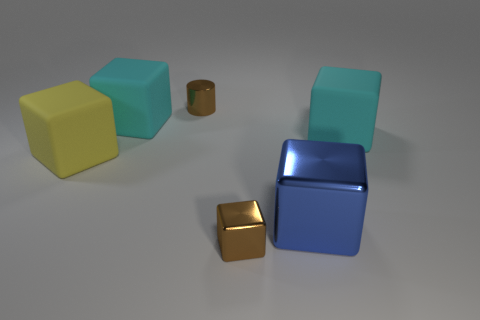What material is the small brown cylinder?
Ensure brevity in your answer.  Metal. There is a metal thing that is behind the blue metal thing; is its shape the same as the blue metal object?
Ensure brevity in your answer.  No. There is a thing that is the same color as the small cube; what is its size?
Your answer should be compact. Small. Are there any blue things that have the same size as the yellow rubber thing?
Keep it short and to the point. Yes. There is a big matte object that is to the right of the tiny thing behind the blue cube; are there any big blue metal blocks behind it?
Give a very brief answer. No. There is a tiny metallic cylinder; does it have the same color as the small shiny thing that is in front of the yellow object?
Ensure brevity in your answer.  Yes. The tiny brown thing behind the big yellow matte cube left of the tiny object that is behind the large yellow object is made of what material?
Ensure brevity in your answer.  Metal. There is a brown metal thing that is in front of the big yellow cube; what is its shape?
Give a very brief answer. Cube. There is a blue object that is made of the same material as the tiny brown cylinder; what size is it?
Provide a short and direct response. Large. How many other rubber things have the same shape as the yellow thing?
Keep it short and to the point. 2. 